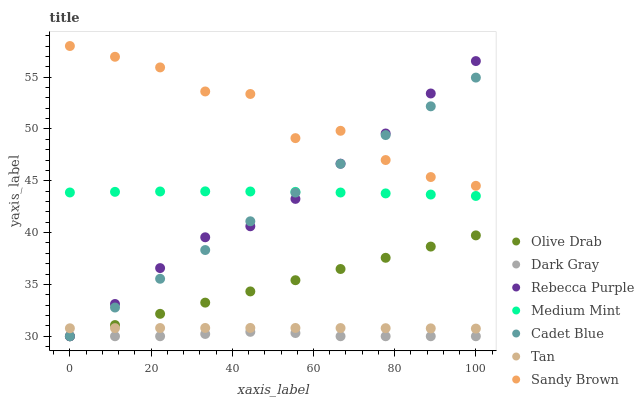Does Dark Gray have the minimum area under the curve?
Answer yes or no. Yes. Does Sandy Brown have the maximum area under the curve?
Answer yes or no. Yes. Does Cadet Blue have the minimum area under the curve?
Answer yes or no. No. Does Cadet Blue have the maximum area under the curve?
Answer yes or no. No. Is Olive Drab the smoothest?
Answer yes or no. Yes. Is Sandy Brown the roughest?
Answer yes or no. Yes. Is Cadet Blue the smoothest?
Answer yes or no. No. Is Cadet Blue the roughest?
Answer yes or no. No. Does Cadet Blue have the lowest value?
Answer yes or no. Yes. Does Tan have the lowest value?
Answer yes or no. No. Does Sandy Brown have the highest value?
Answer yes or no. Yes. Does Cadet Blue have the highest value?
Answer yes or no. No. Is Dark Gray less than Sandy Brown?
Answer yes or no. Yes. Is Medium Mint greater than Dark Gray?
Answer yes or no. Yes. Does Cadet Blue intersect Tan?
Answer yes or no. Yes. Is Cadet Blue less than Tan?
Answer yes or no. No. Is Cadet Blue greater than Tan?
Answer yes or no. No. Does Dark Gray intersect Sandy Brown?
Answer yes or no. No. 